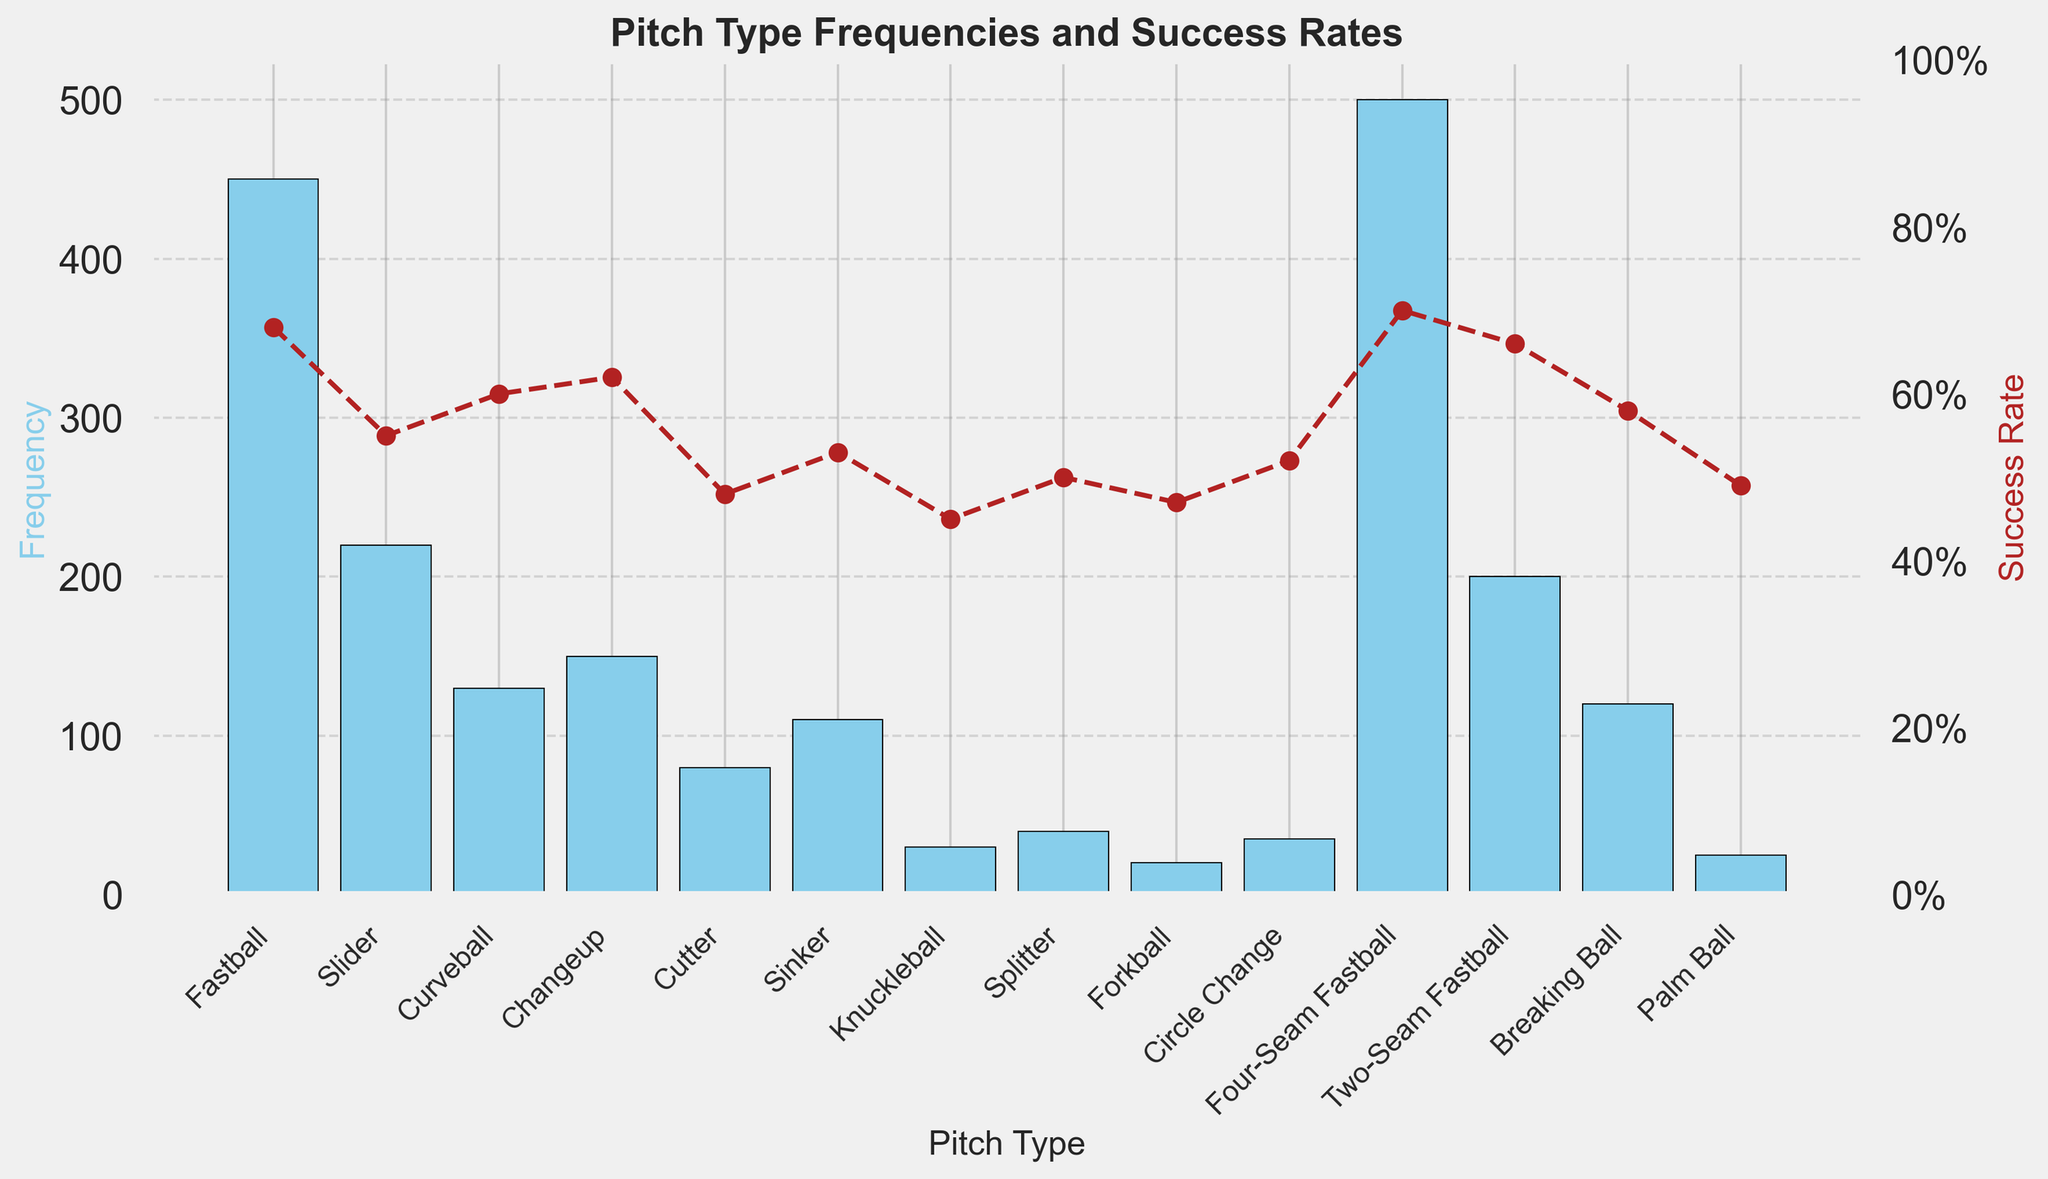What is the most frequently thrown pitch type and what is its success rate? The tallest bar indicates the most frequent pitch type, which is the Four-Seam Fastball with a frequency of 500 pitches. Directly above this data point is a corresponding marker representing the success rate, which stands at 0.70 or 70%.
Answer: Four-Seam Fastball, 70% Which pitch type has the lowest success rate, and what is its frequency? The lowest data point on the secondary y-axis, representing success rates, corresponds to the Knuckleball, which has a success rate of 0.45 or 45%. The frequency of the Knuckleball can be found directly below its respective bar, which is 30 pitches.
Answer: Knuckleball, 30 What is the combined frequency of the Three-Seam Fastball and the Two-Seam Fastball pitches? From the bar chart, the frequency of the Four-Seam Fastball is 500, and the frequency of the Two-Seam Fastball is 200. Adding these two numbers together gives a combined frequency of 500 + 200 = 700 pitches.
Answer: 700 Which pitch type appears third most frequently and how does its success rate compare to the Sinker? From the bars, the third tallest bar represents the Fastball with a frequency of 450. The success rate of the Fastball, as indicated by its corresponding marker, is 0.68 or 68%. Comparing this to the Sinker, which has a success rate of 0.53 or 53%, the Fastball has a higher success rate.
Answer: Fastball, higher How many pitch types have a success rate above 0.60? The markers on the secondary y-axis indicate the success rates. The pitch types with success rates above 0.60 are Four-Seam Fastball (0.70), Fastball (0.68), Two-Seam Fastball (0.66), and Changeup (0.62). Therefore, there are 4 pitch types with a success rate above 0.60.
Answer: 4 Which has a greater frequency: the sum of the Curveball and Changeup, or the Slider? From the data, the frequency of the Curveball is 130 and the Changeup is 150. Adding these gives 130 + 150 = 280 pitches. The frequency of the Slider is 220. Comparing these values, 280 (Curveball + Changeup) is greater than 220 (Slider).
Answer: Curveball + Changeup Which pitch type has both a frequency and success rate below 50, and what are its exact values? From observing the bar chart, the only pitch type with a frequency below 50 and a success rate below 0.50 is the Forkball. Its frequency is 20 and its success rate is 0.47 or 47%.
Answer: Forkball, 20, 47% What is the difference between the success rates of the Circle Change and the Breaking Ball pitches? The success rate of the Circle Change is 0.52 or 52%, and the success rate of the Breaking Ball is 0.58 or 58%. The difference between these two success rates is 58% - 52% = 6%.
Answer: 6% Which pitch type has the closest success rate to the Cutter, and what is it? The success rate of the Cutter is 0.48 or 48%. The nearest success rate to this is the Palm Ball with a success rate of 0.49 or 49%.
Answer: Palm Ball, 0.49 What is the average success rate of all pitch types? To find the average success rate, sum all individual success rates divided by the number of pitch types. The total of success rates is (0.68 + 0.55 + 0.60 + 0.62 + 0.48 + 0.53 + 0.45 + 0.50 + 0.47 + 0.52 + 0.70 + 0.66 + 0.58 + 0.49) = 7.33. There are 14 pitch types. The average success rate is 7.33 / 14 ≈ 0.52 or 52%.
Answer: 52% 